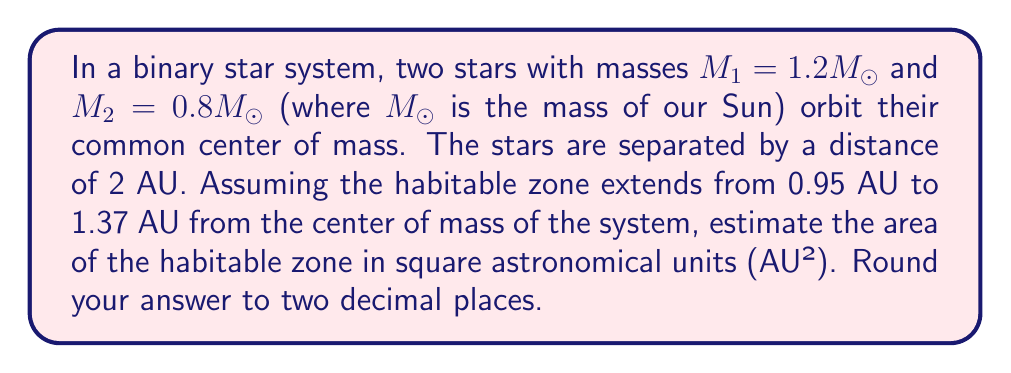Can you answer this question? Let's approach this step-by-step:

1) First, we need to determine the center of mass of the system. Given that the total separation is 2 AU, we can use the center of mass formula:

   $$x_1 = \frac{M_2}{M_1 + M_2} \cdot 2\text{ AU}$$

   $$x_1 = \frac{0.8}{1.2 + 0.8} \cdot 2\text{ AU} = 0.8\text{ AU}$$

   The center of mass is 0.8 AU from the more massive star.

2) Now, we can visualize the habitable zone as an annulus (ring-shaped region) around the center of mass. The inner radius is 0.95 AU and the outer radius is 1.37 AU.

3) The area of an annulus is given by the formula:

   $$A = \pi(R^2 - r^2)$$

   Where R is the outer radius and r is the inner radius.

4) Plugging in our values:

   $$A = \pi(1.37^2 - 0.95^2)$$
   $$A = \pi(1.8769 - 0.9025)$$
   $$A = \pi(0.9744)$$
   $$A = 3.0614\text{ AU}^2$$

5) Rounding to two decimal places:

   $$A \approx 3.06\text{ AU}^2$$
Answer: $3.06\text{ AU}^2$ 